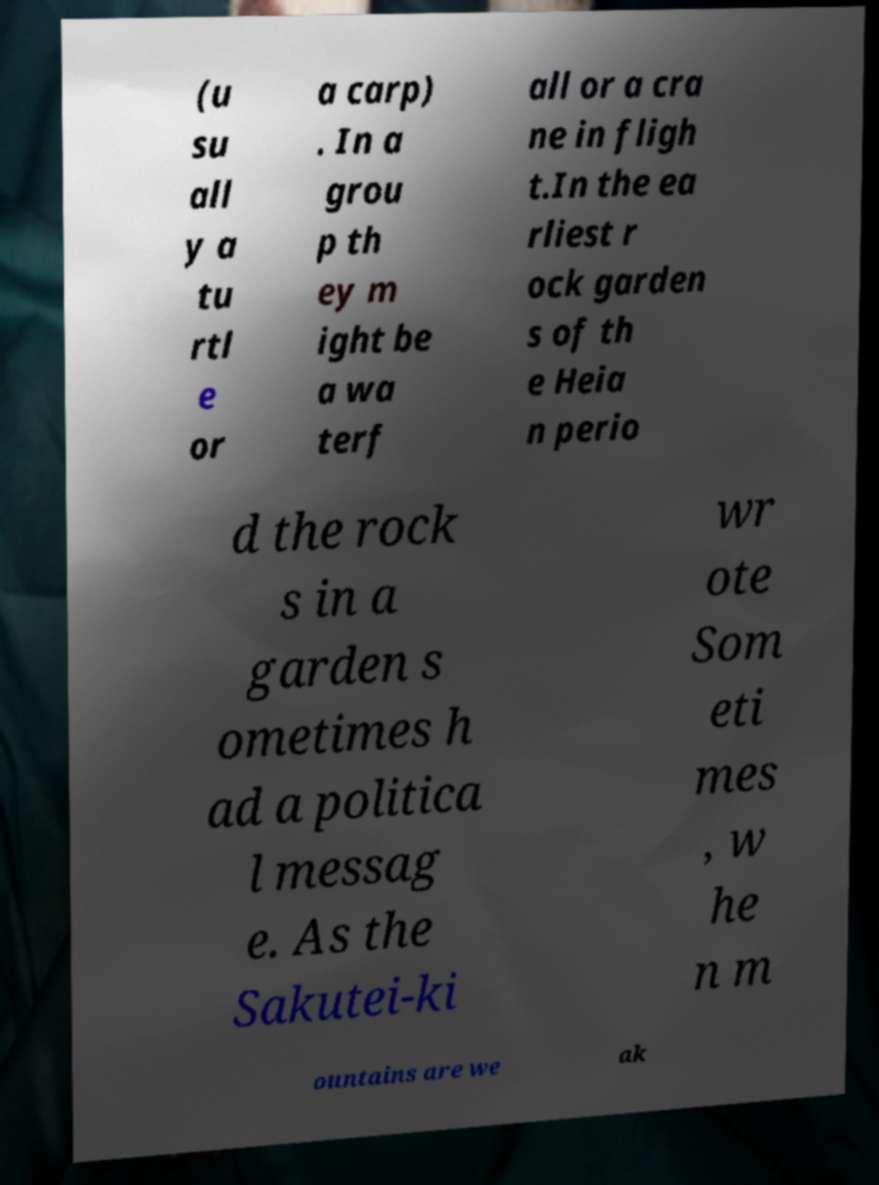Could you extract and type out the text from this image? (u su all y a tu rtl e or a carp) . In a grou p th ey m ight be a wa terf all or a cra ne in fligh t.In the ea rliest r ock garden s of th e Heia n perio d the rock s in a garden s ometimes h ad a politica l messag e. As the Sakutei-ki wr ote Som eti mes , w he n m ountains are we ak 